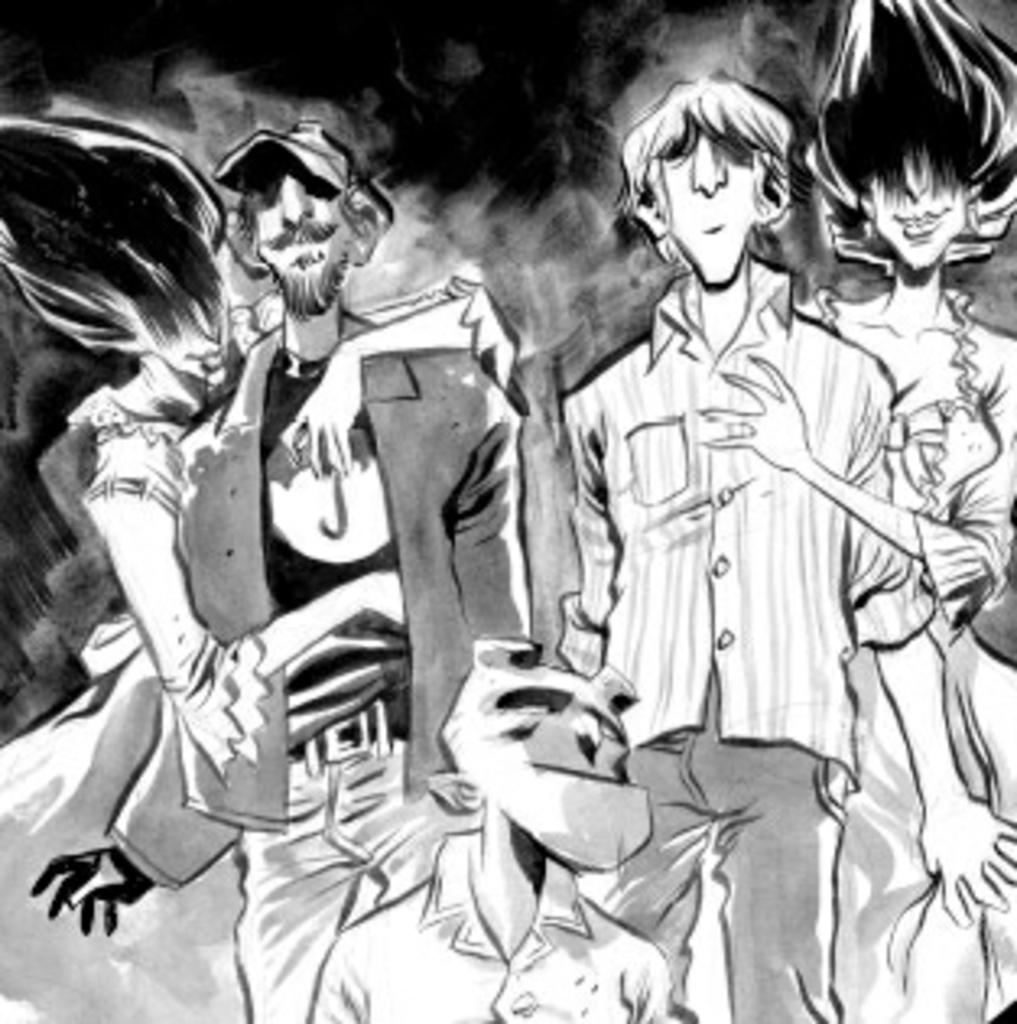How many people are in the image? The number of people in the image cannot be determined from the given fact. What type of vein is visible in the image? There is no vein present in the image. What kind of bun is being held by one of the persons in the image? The given fact does not mention any buns or specific objects being held by the persons in the image. 